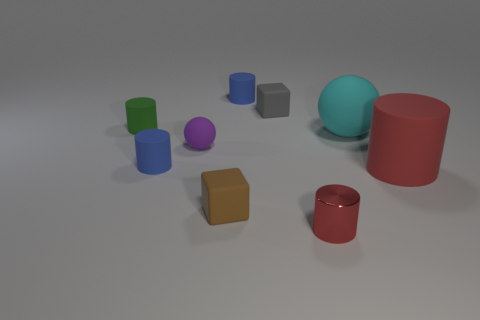Subtract 2 cylinders. How many cylinders are left? 3 Subtract all small red cylinders. How many cylinders are left? 4 Subtract all green cylinders. How many cylinders are left? 4 Subtract all gray cylinders. Subtract all purple balls. How many cylinders are left? 5 Add 1 small gray matte blocks. How many objects exist? 10 Subtract all balls. How many objects are left? 7 Subtract 1 brown blocks. How many objects are left? 8 Subtract all red matte things. Subtract all tiny purple rubber objects. How many objects are left? 7 Add 1 small blue cylinders. How many small blue cylinders are left? 3 Add 9 large red rubber cylinders. How many large red rubber cylinders exist? 10 